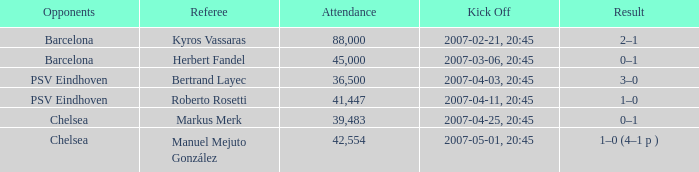WHAT WAS THE SCORE OF THE GAME WITH A 2007-03-06, 20:45 KICKOFF? 0–1. 